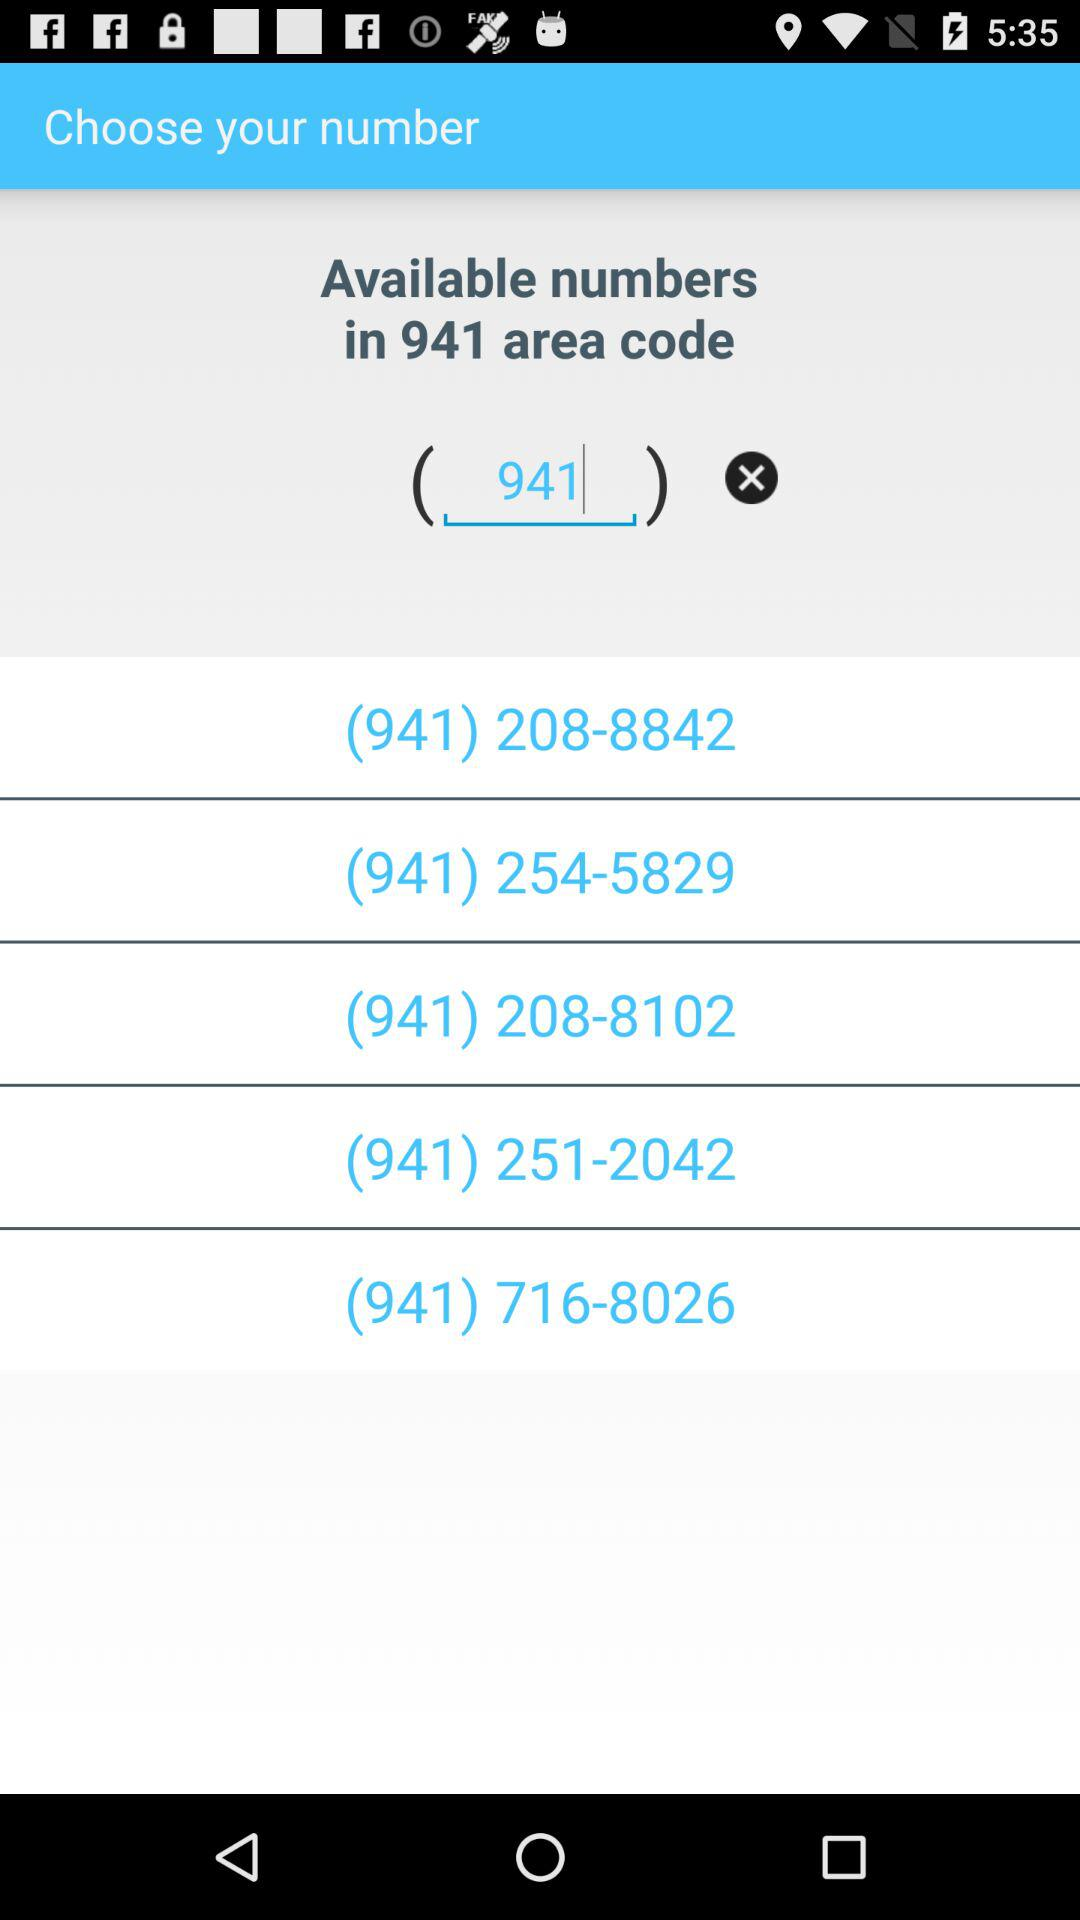What are the phone numbers with the area code 941? The phone numbers with the area code 941 are (941) 208-8842, (941) 254-5829, (941) 208-8102, (941) 251-2042 and (941) 716-8026. 